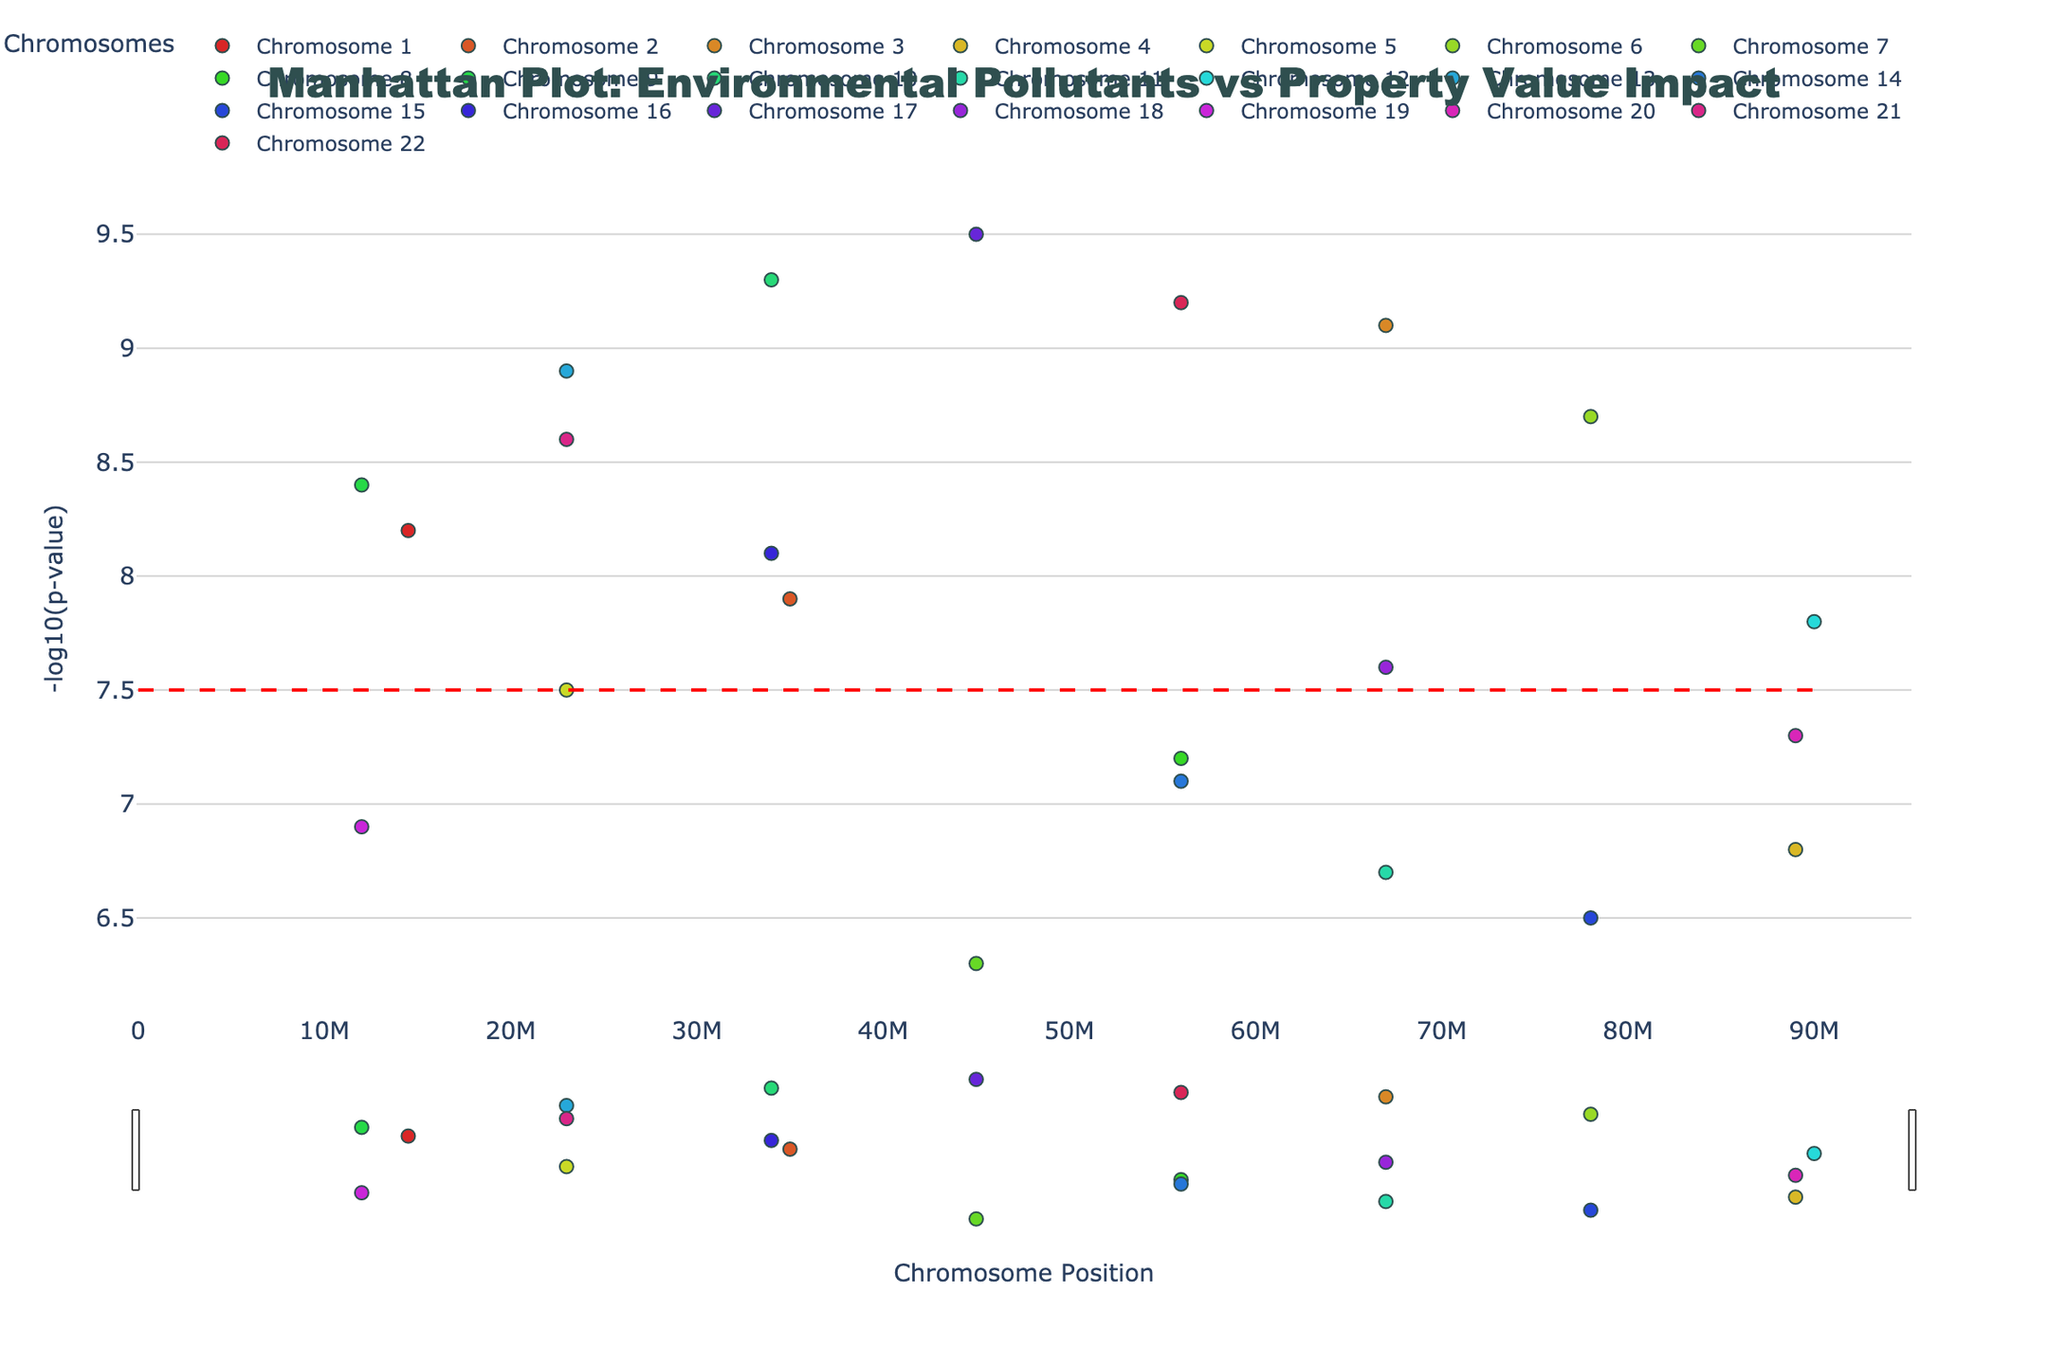What is the title of the plot? The title is located at the top of the plot, it reads: "Manhattan Plot: Environmental Pollutants vs Property Value Impact".
Answer: Manhattan Plot: Environmental Pollutants vs Property Value Impact How many pollutants have a -log10(p-value) greater than the threshold line of 7.5? To determine this, count the number of points above the red threshold line. Visual inspection shows several points above this line.
Answer: 17 Which pollutant has the highest -log10(p-value) and what is its value? The point with the highest position on the y-axis represents the highest -log10(p-value). Based on the hovering text, it's 'Arsenic' with a value of 9.5.
Answer: Arsenic, 9.5 Which pollutant is located on Chromosome 10, and what is its -log10(p-value)? Find the group of points for Chromosome 10 on the x-axis, hover to identify the pollutant, and note the y-value. The pollutant is 'Particulate Matter' at a value of 9.3.
Answer: Particulate Matter, 9.3 How many pollutants are between Chromosome 5 and Chromosome 12 with -log10(p-value) above 8? Identify the points within this chromosomal range and count those above the value of 8 on the y-axis. There are several such points.
Answer: 5 Which pollutants are located on Chromosome 1, and what are their -log10(p-values)? Examine the points for Chromosome 1 and hover over them to identify pollutants and their y-values. The pollutant is 'Lead' with a value of 8.2.
Answer: Lead, 8.2 What pollutant is represented with the lowest -log10(p-value) on the plot, and what is its value? Identify the lowest point on the y-axis and hover to see the pollutant name and its value. The pollutant is 'PCBs' with a value of 6.3.
Answer: PCBs, 6.3 Compare the -log10(p-value) of 'Ozone' with 'PFAS'. Which is higher and by how much? Locate the points for 'Ozone' and 'PFAS' by hovering over the relevant chromosomes. The difference between 'Ozone' (8.9) and 'PFAS' (8.6) is calculated.
Answer: Ozone is higher by 0.3 Summarize pollutants on Chromosome 3 and Chromosome 18. Provide the pollutants and their -log10(p-values). Check Chromosomes 3 and 18, hover to gather pollutant names and their y-values. Chromosome 3 has 'Radon' (9.1), and Chromosome 18 has 'Cadmium' (7.6).
Answer: Radon (9.1), Cadmium (7.6) Which pollutant is closest to the median -log10(p-value) of all pollutants? Calculate the median of the provided y-values, then determine which pollutant's y-value is closest. The median value is around 7.7, closest is 'Cadmium' (7.6).
Answer: Cadmium 